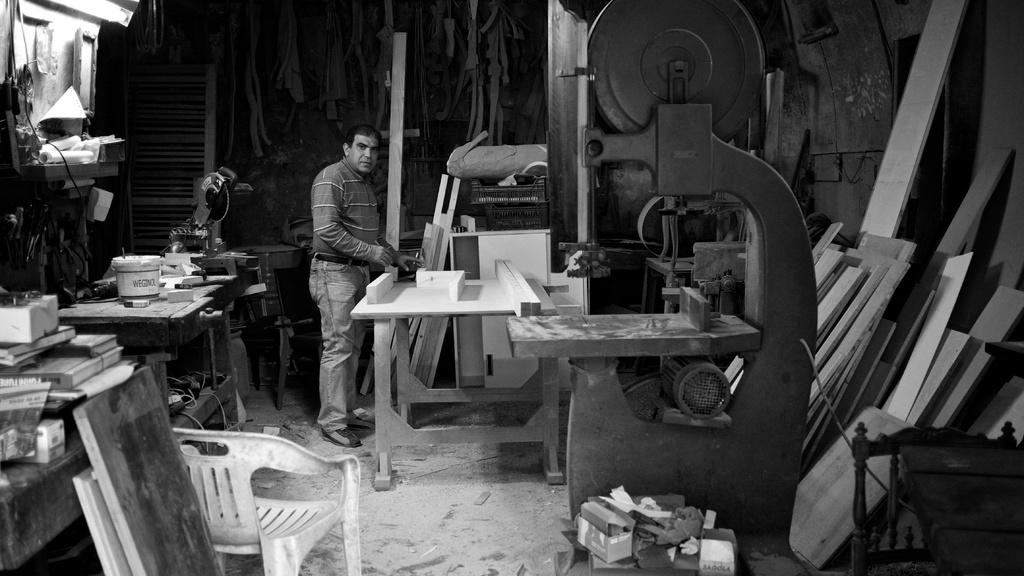How would you describe the state of the room in the image? The room appears to be untidy. Can you identify any people in the room? Yes, there is a man standing in the room. What piece of furniture is visible in the front of the room? There is a chair in the front of the room. What type of items can be seen in the room? There are electrical equipment in the room. How many pizzas are being delivered to the room in the image? There are no pizzas visible in the image, nor is there any indication of a delivery. Can you see any snails crawling on the floor in the image? There are no snails present in the image. 